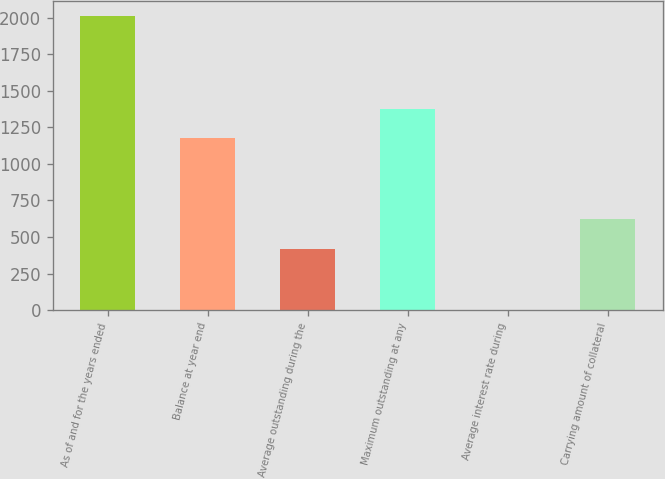Convert chart. <chart><loc_0><loc_0><loc_500><loc_500><bar_chart><fcel>As of and for the years ended<fcel>Balance at year end<fcel>Average outstanding during the<fcel>Maximum outstanding at any<fcel>Average interest rate during<fcel>Carrying amount of collateral<nl><fcel>2012<fcel>1178.3<fcel>419.5<fcel>1379.38<fcel>1.23<fcel>620.58<nl></chart> 